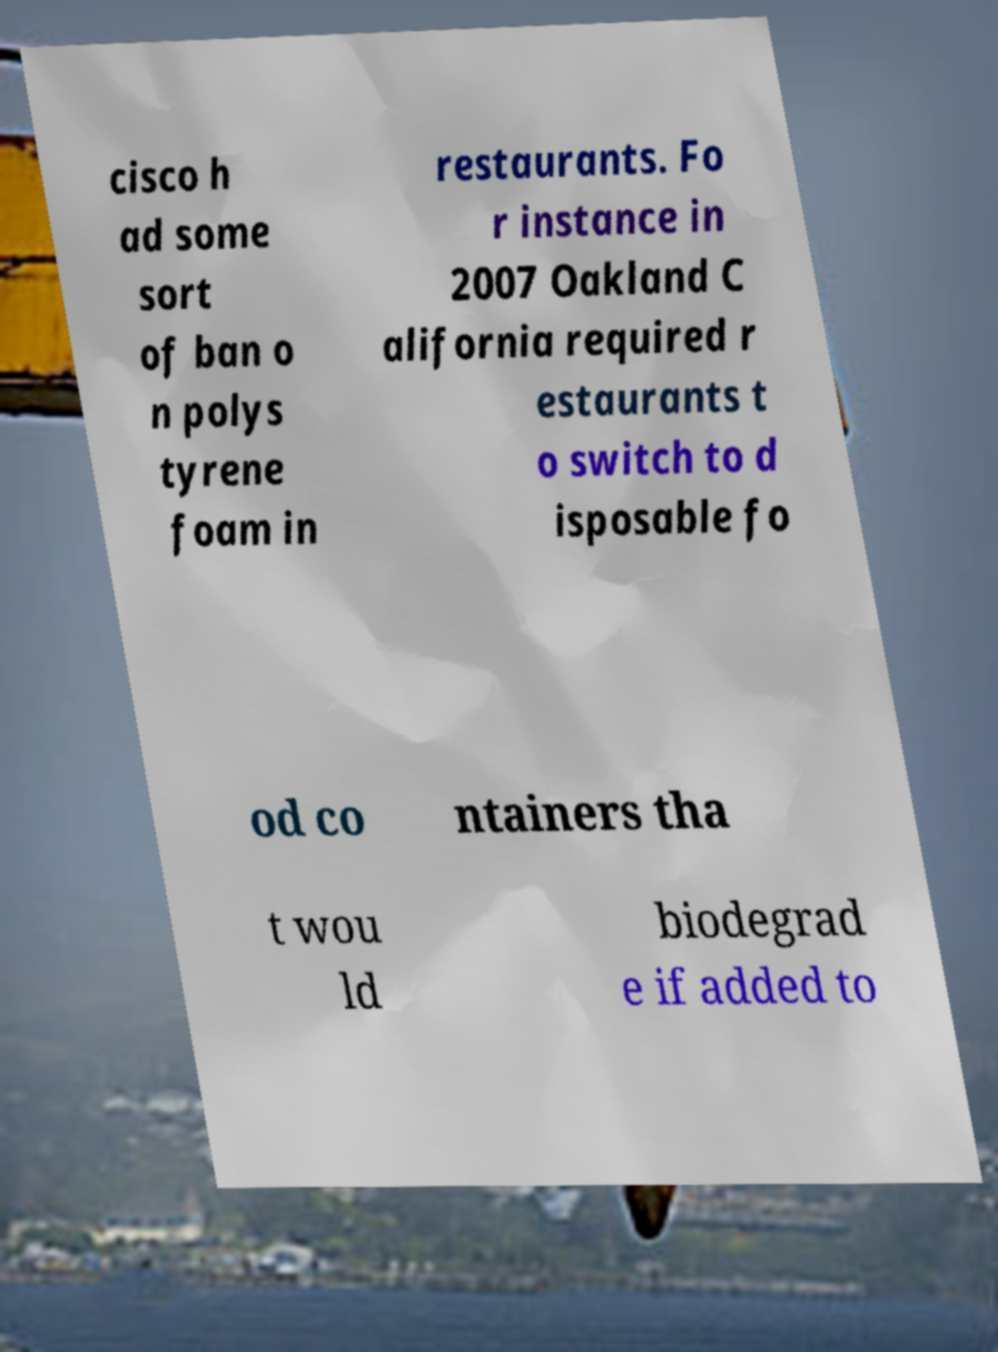Could you assist in decoding the text presented in this image and type it out clearly? cisco h ad some sort of ban o n polys tyrene foam in restaurants. Fo r instance in 2007 Oakland C alifornia required r estaurants t o switch to d isposable fo od co ntainers tha t wou ld biodegrad e if added to 